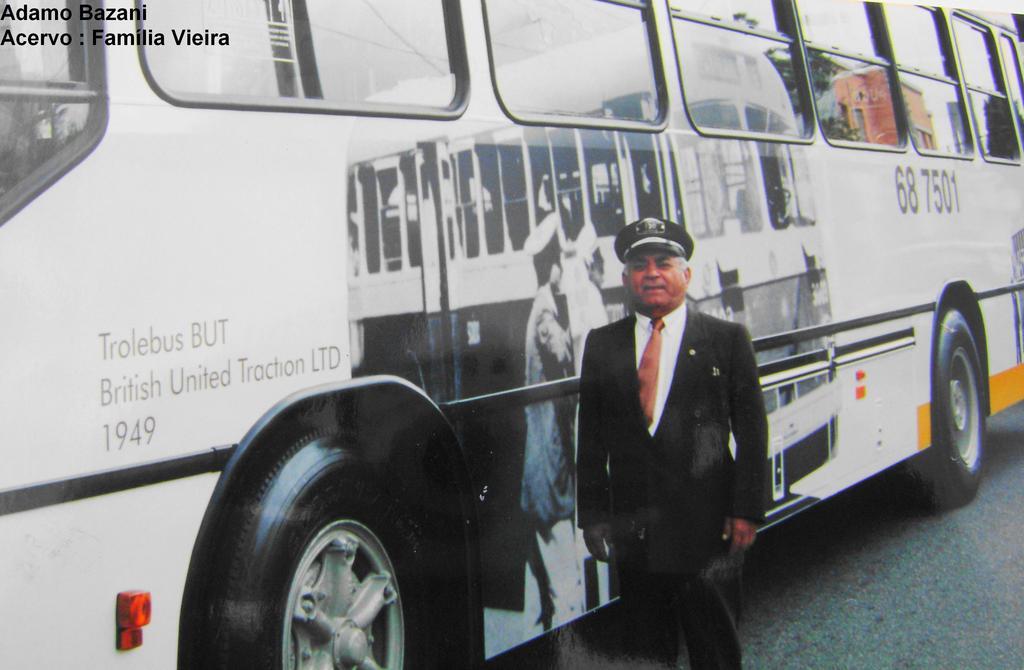What year is written on the bus?
Make the answer very short. 1949. What is the bus number?
Offer a terse response. 68 7501. 